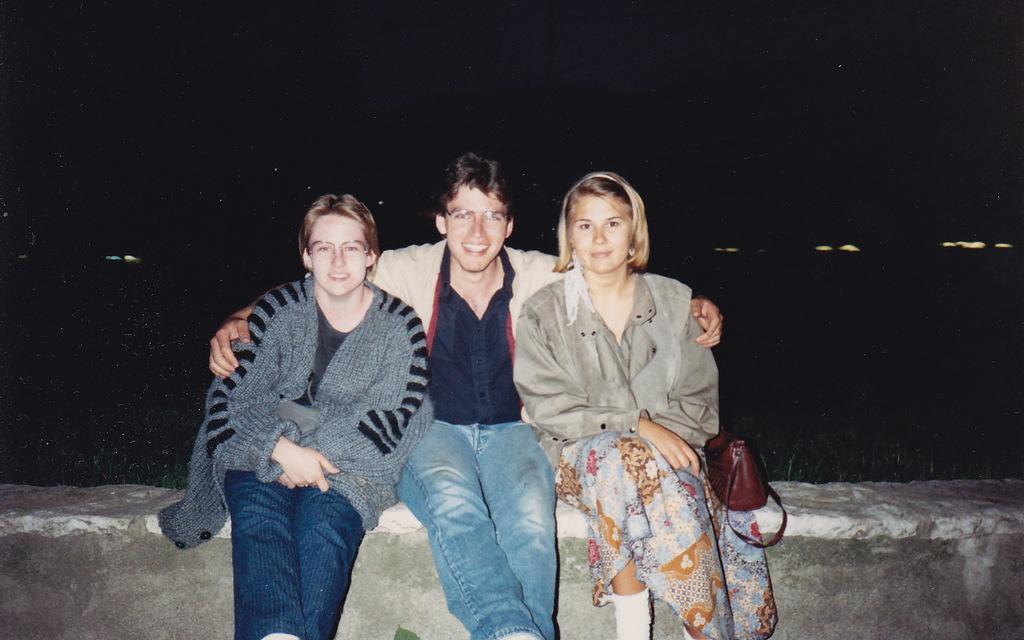Can you describe this image briefly? In this image we can see few persons are sitting on a platform and there is a hand bag on the platform. In the background the image is dark but we can see the lights. 